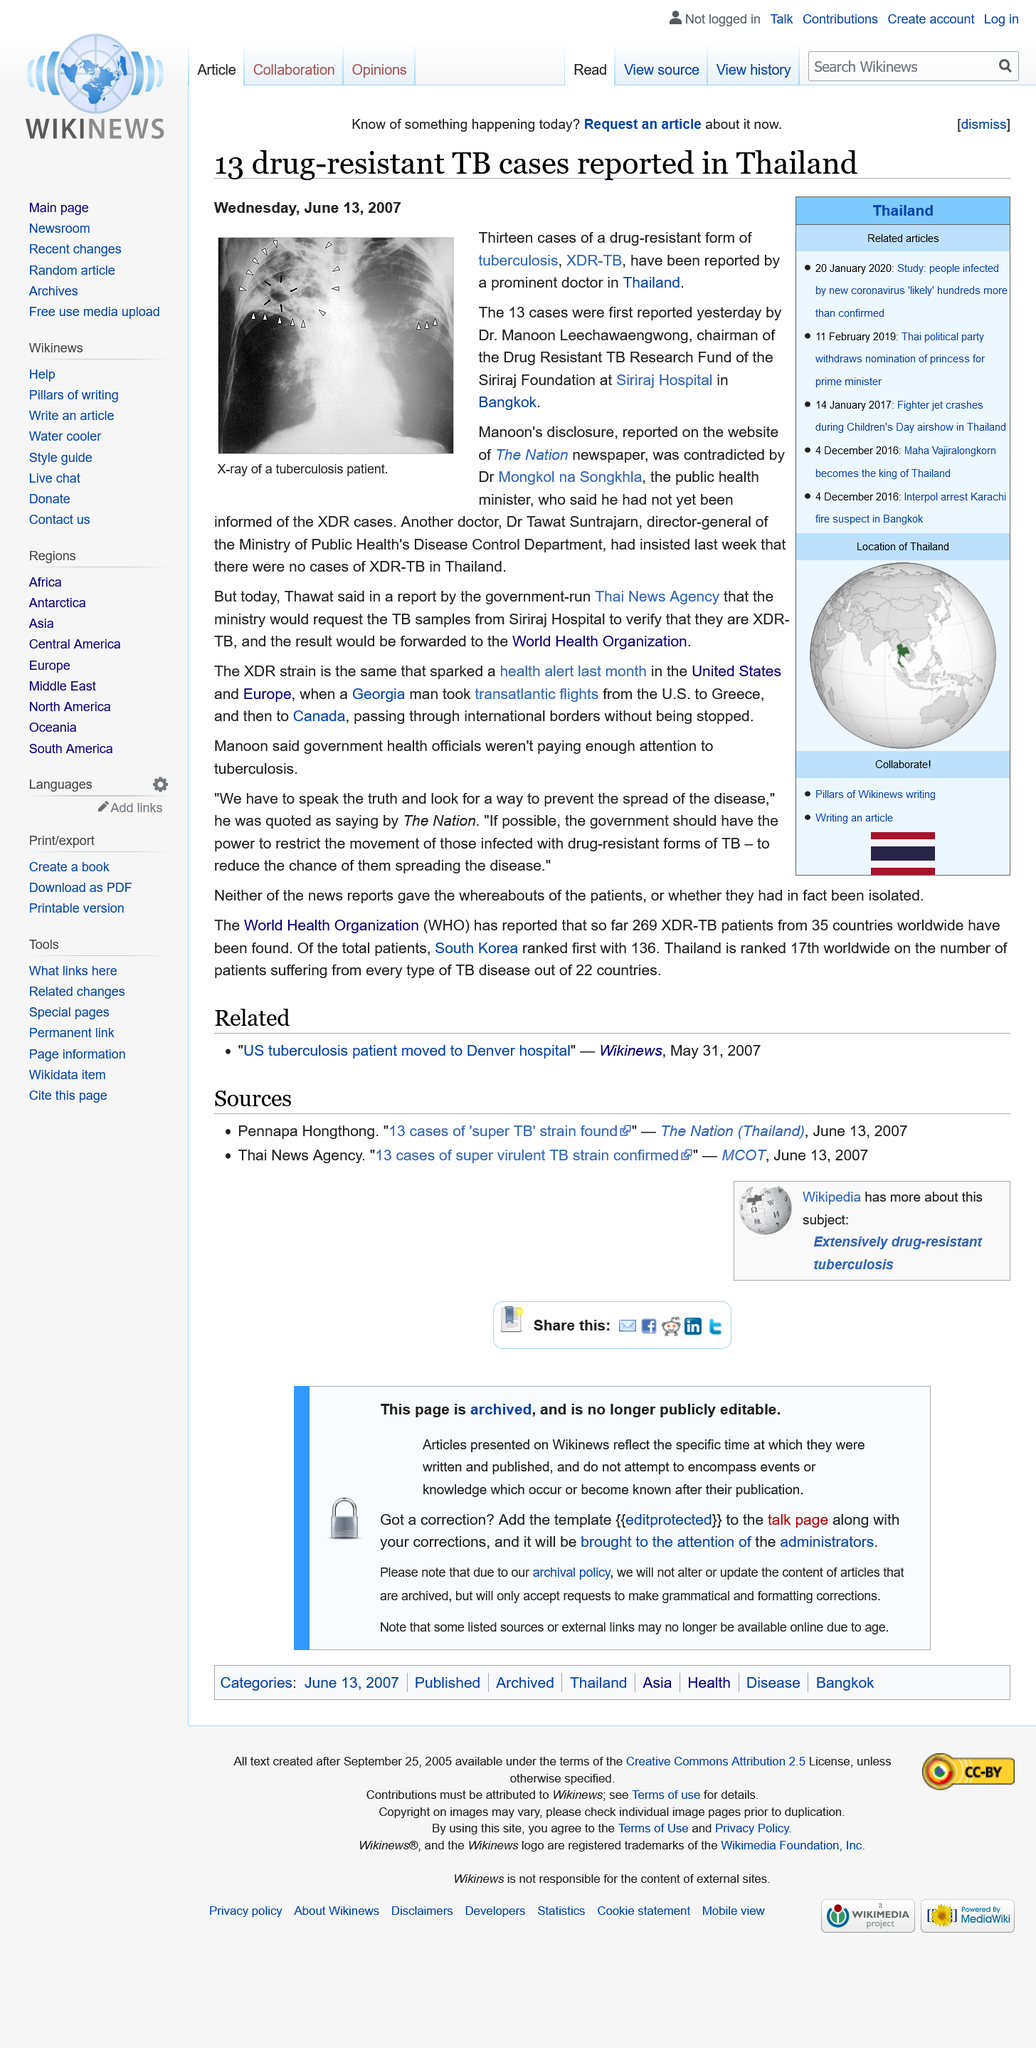Point out several critical features in this image. Dr. Manoon Leechawaengwong is the chairman of the Drug Resistant TB Research Fund of the Siriraj Foundation. He is a renowned leader in the field of medical research and has made significant contributions to the field of drug-resistant tuberculosis. As the chairman of this fund, he is responsible for overseeing the research and development of new treatments for this disease. The image depicts an X-ray of the chest of a patient with tuberculosis, revealing the characteristic lesions and cavities characteristic of the disease. I, Dr. Manoon Leechawaengwong, reported the thirteen cases of drug-resistant tuberculosis. 